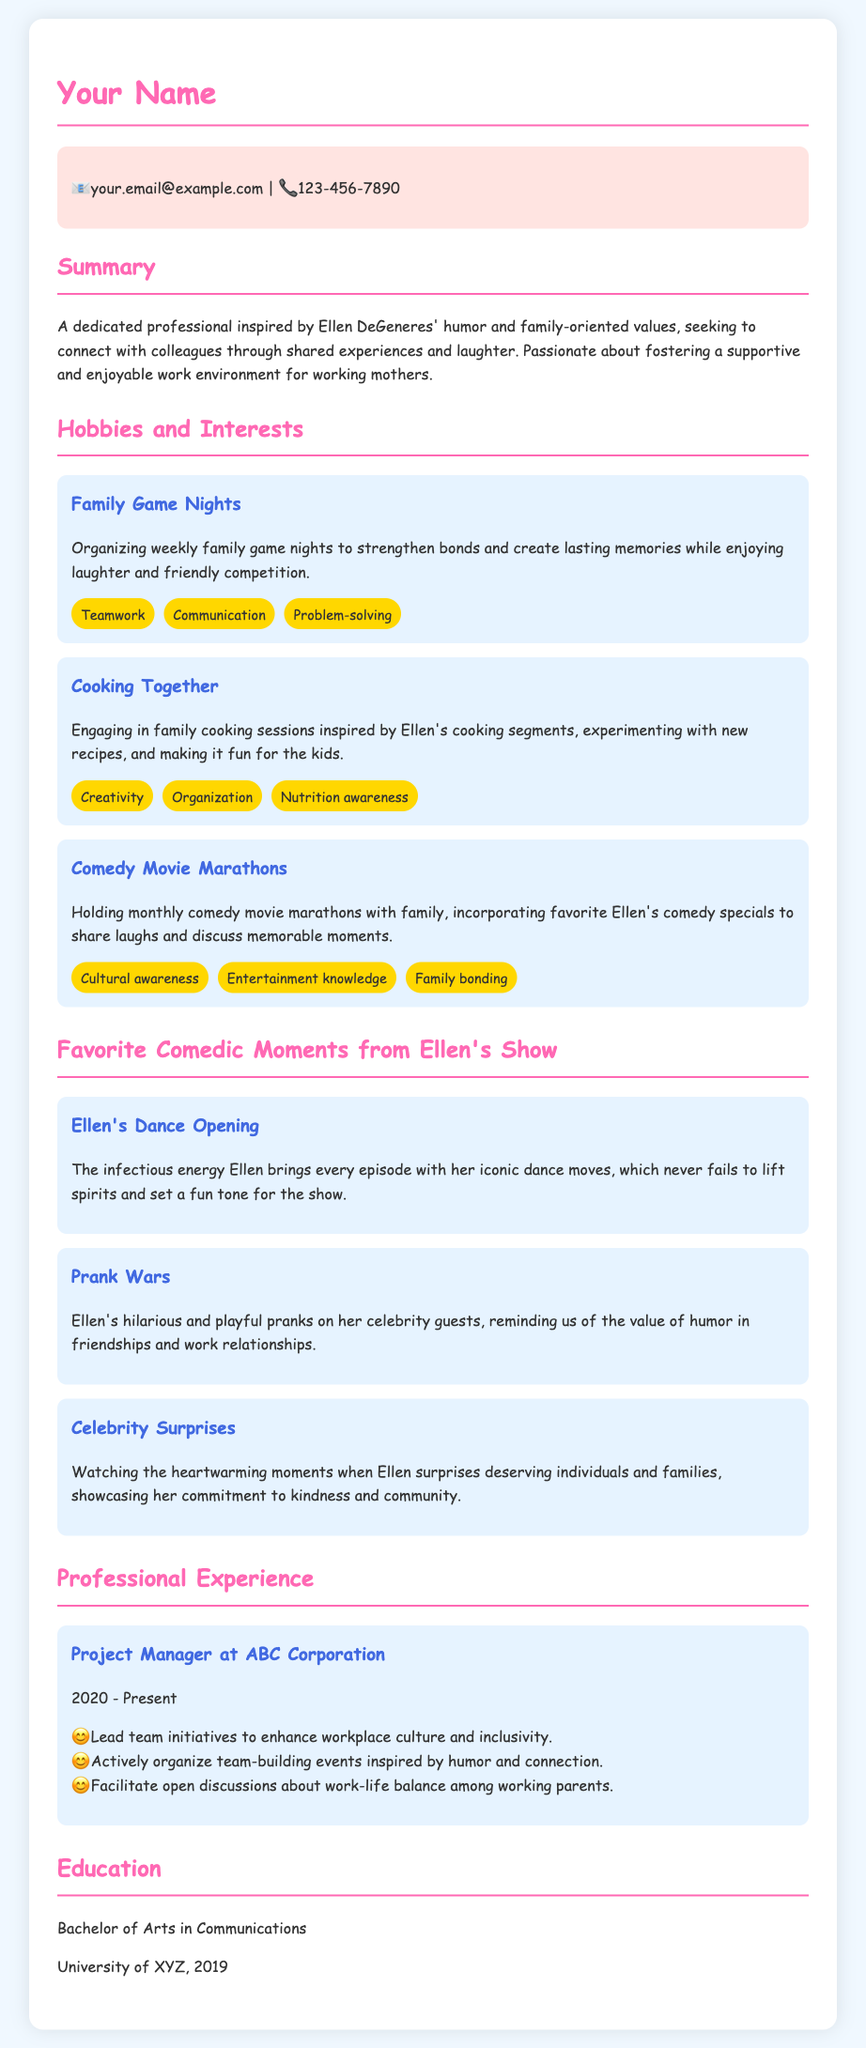what is the person's email address? The email address provided in the contact information section of the document is listed.
Answer: your.email@example.com what hobbies involve cooking? The hobbies mentioned in the document refer to family activities, which include cooking together.
Answer: Cooking Together how often are family game nights organized? The document states that family game nights are organized on a specific weekly basis.
Answer: Weekly which Ellen moment involves pranks? The document highlights a specific moment from Ellen's show that features pranks on celebrity guests.
Answer: Prank Wars what is the educational qualification mentioned? The document specifies the degree received by the individual, which is outlined in the education section.
Answer: Bachelor of Arts in Communications how does the person like to bond with family? The document lists specific activities that promote family bonding, which includes comedy movie marathons.
Answer: Comedy Movie Marathons what type of events does the person organize at work? The document discusses the kinds of initiatives led by the individual to enhance workplace culture.
Answer: Team-building events which segment of Ellen's show is associated with dance? The document references a popular segment that features energetic dance and is a signature part of the show.
Answer: Ellen's Dance Opening 